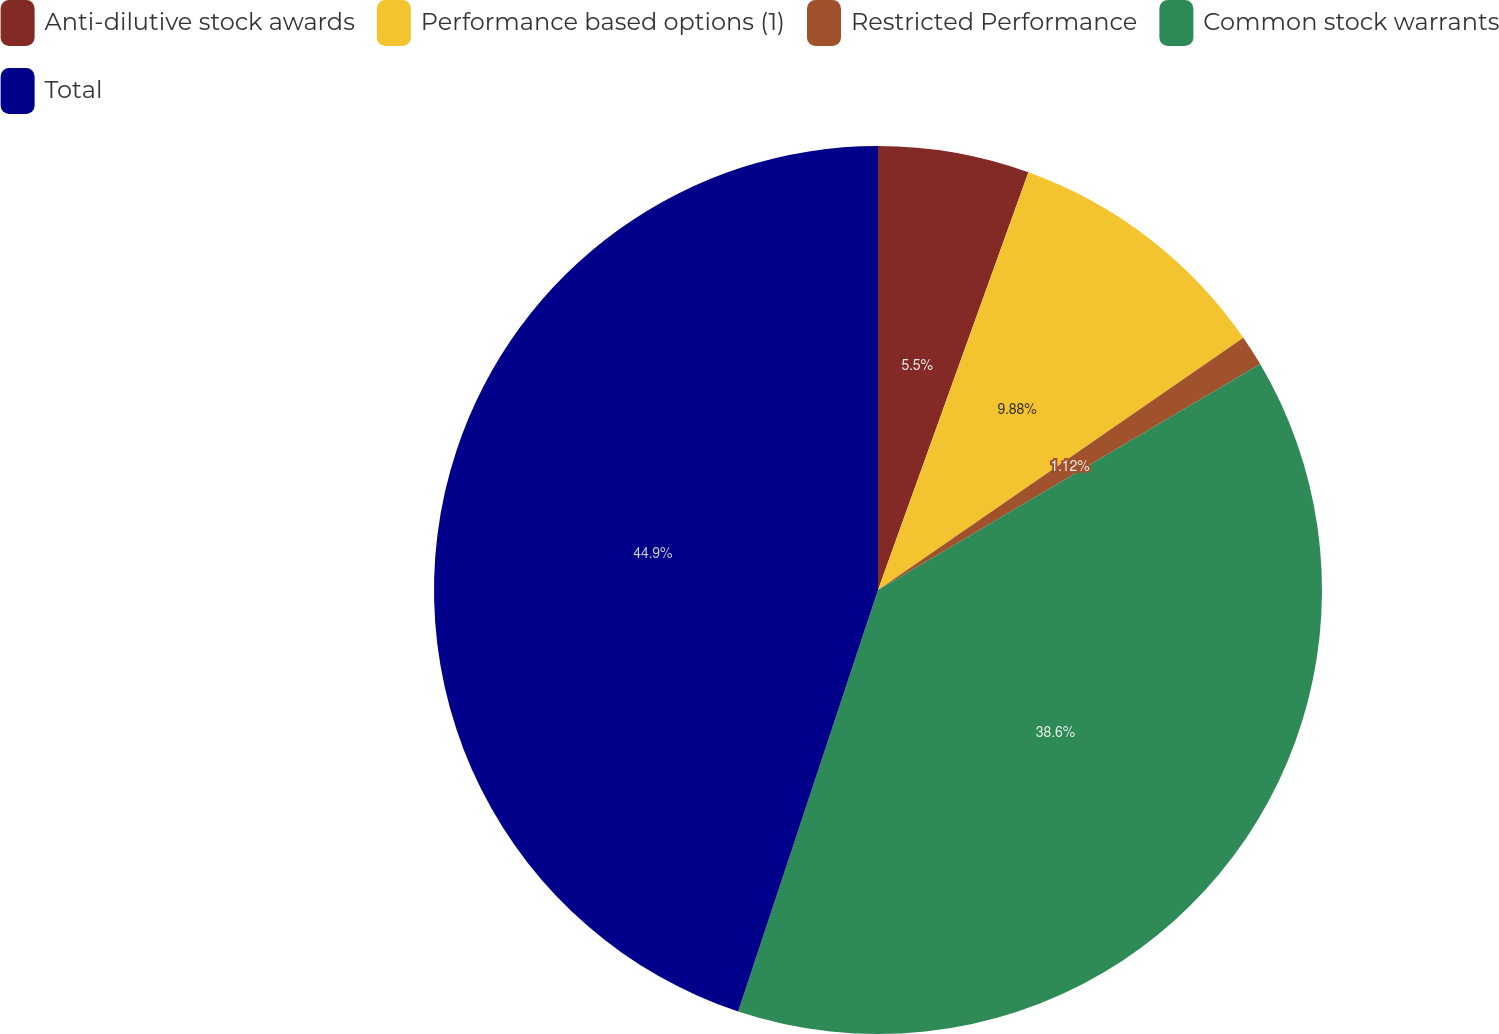Convert chart to OTSL. <chart><loc_0><loc_0><loc_500><loc_500><pie_chart><fcel>Anti-dilutive stock awards<fcel>Performance based options (1)<fcel>Restricted Performance<fcel>Common stock warrants<fcel>Total<nl><fcel>5.5%<fcel>9.88%<fcel>1.12%<fcel>38.6%<fcel>44.9%<nl></chart> 